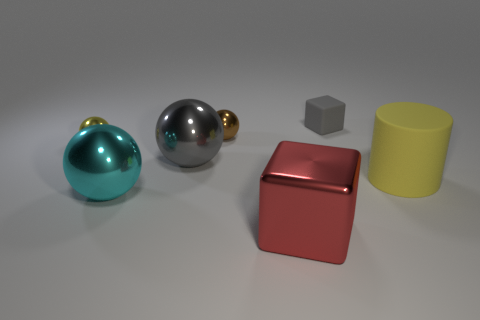Is the color of the small object that is right of the red cube the same as the large shiny cube?
Provide a short and direct response. No. There is a small matte thing; are there any tiny gray blocks behind it?
Provide a succinct answer. No. There is a metal thing that is in front of the yellow ball and behind the yellow matte thing; what color is it?
Keep it short and to the point. Gray. What is the shape of the other thing that is the same color as the big rubber thing?
Provide a short and direct response. Sphere. There is a yellow object left of the small rubber cube to the right of the yellow metal ball; what is its size?
Provide a short and direct response. Small. What number of balls are either red metal objects or big brown matte objects?
Offer a terse response. 0. What is the color of the metallic cube that is the same size as the matte cylinder?
Give a very brief answer. Red. What shape is the matte object that is to the right of the block to the right of the big metallic block?
Your response must be concise. Cylinder. Do the object that is in front of the cyan shiny sphere and the small matte thing have the same size?
Provide a succinct answer. No. How many other objects are the same material as the red cube?
Offer a very short reply. 4. 